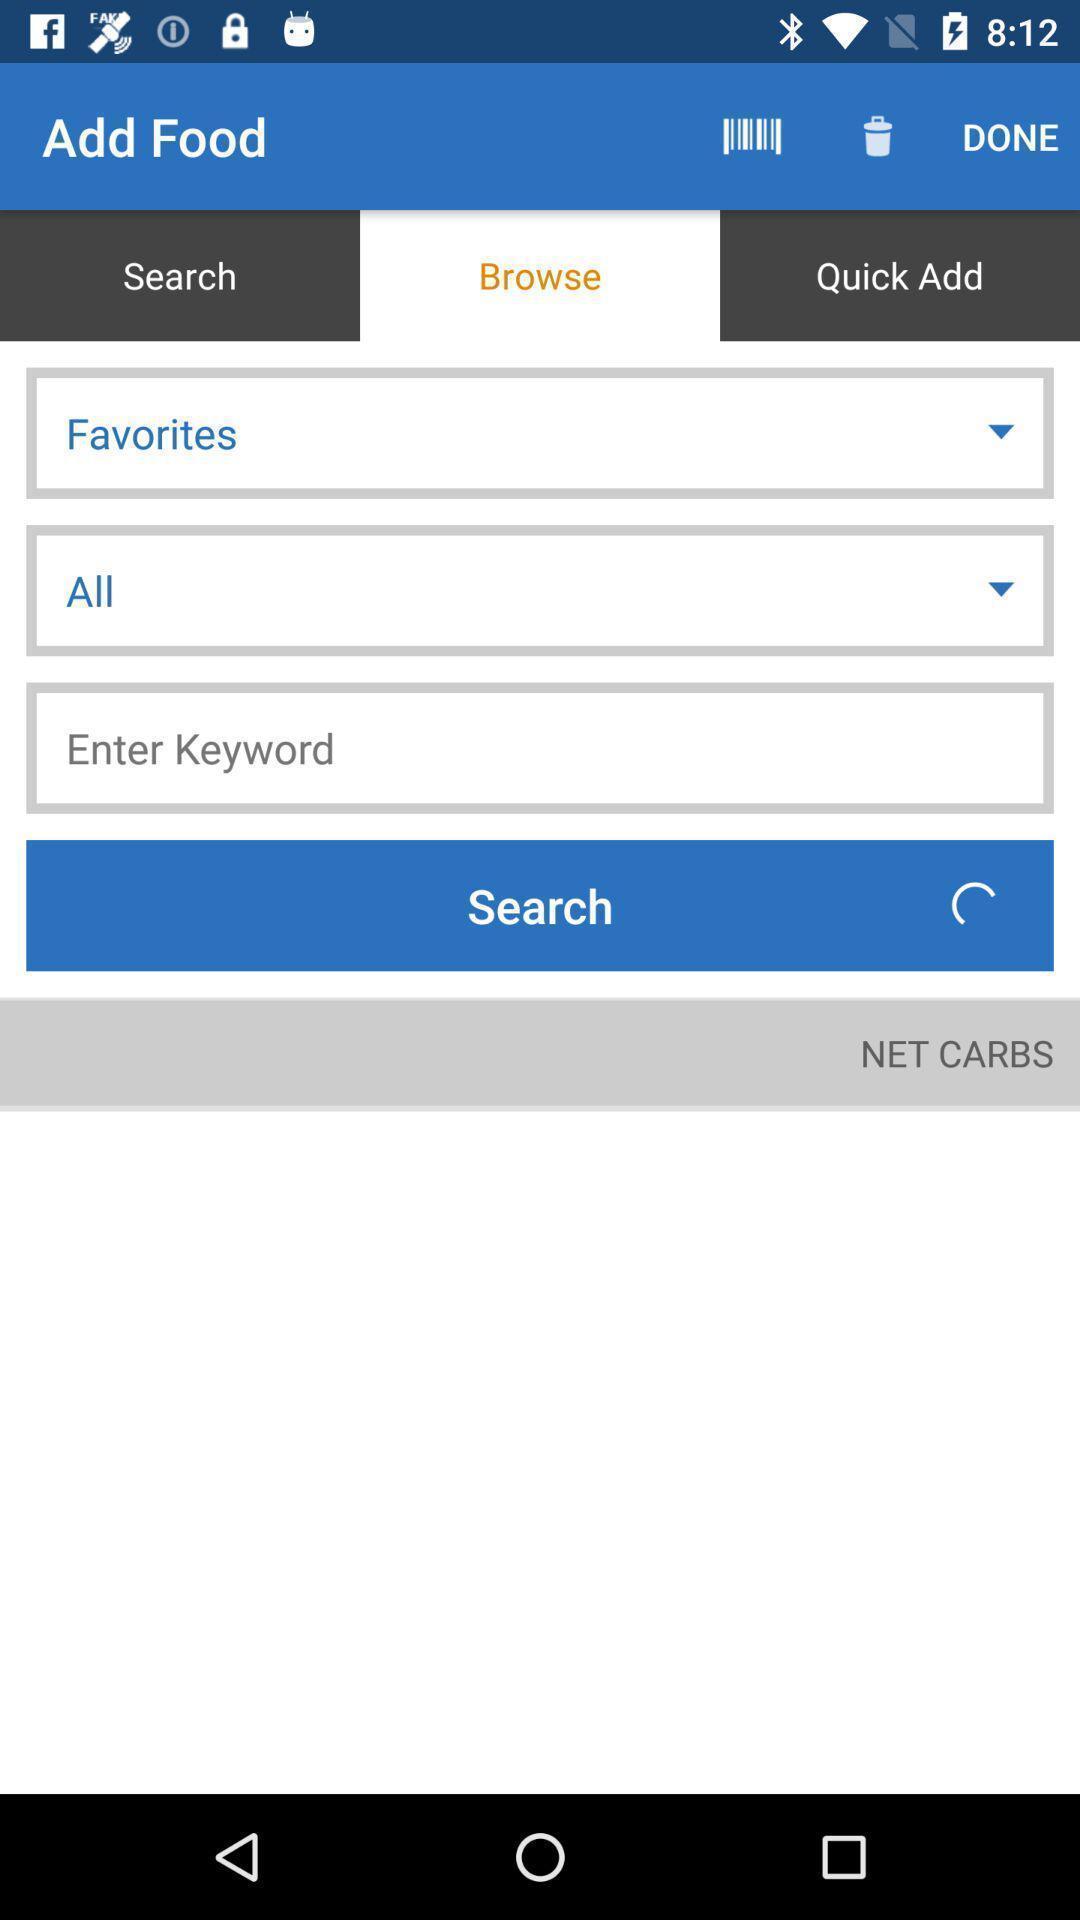Tell me about the visual elements in this screen capture. Page to add food in the carbs calculating app. 